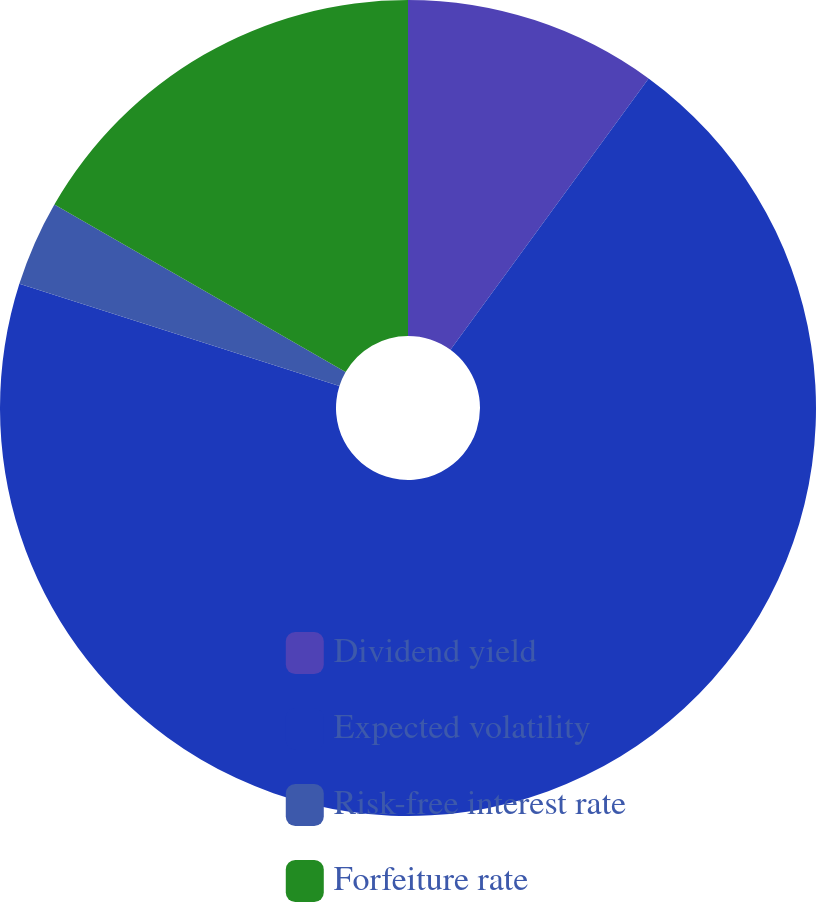Convert chart. <chart><loc_0><loc_0><loc_500><loc_500><pie_chart><fcel>Dividend yield<fcel>Expected volatility<fcel>Risk-free interest rate<fcel>Forfeiture rate<nl><fcel>10.04%<fcel>69.89%<fcel>3.39%<fcel>16.69%<nl></chart> 